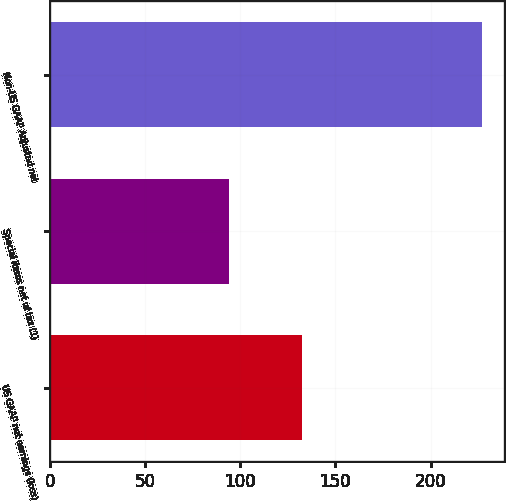Convert chart. <chart><loc_0><loc_0><loc_500><loc_500><bar_chart><fcel>US GAAP net earnings (loss)<fcel>Special items net of tax (1)<fcel>Non-US GAAP Adjusted net<nl><fcel>132.7<fcel>94.3<fcel>227<nl></chart> 